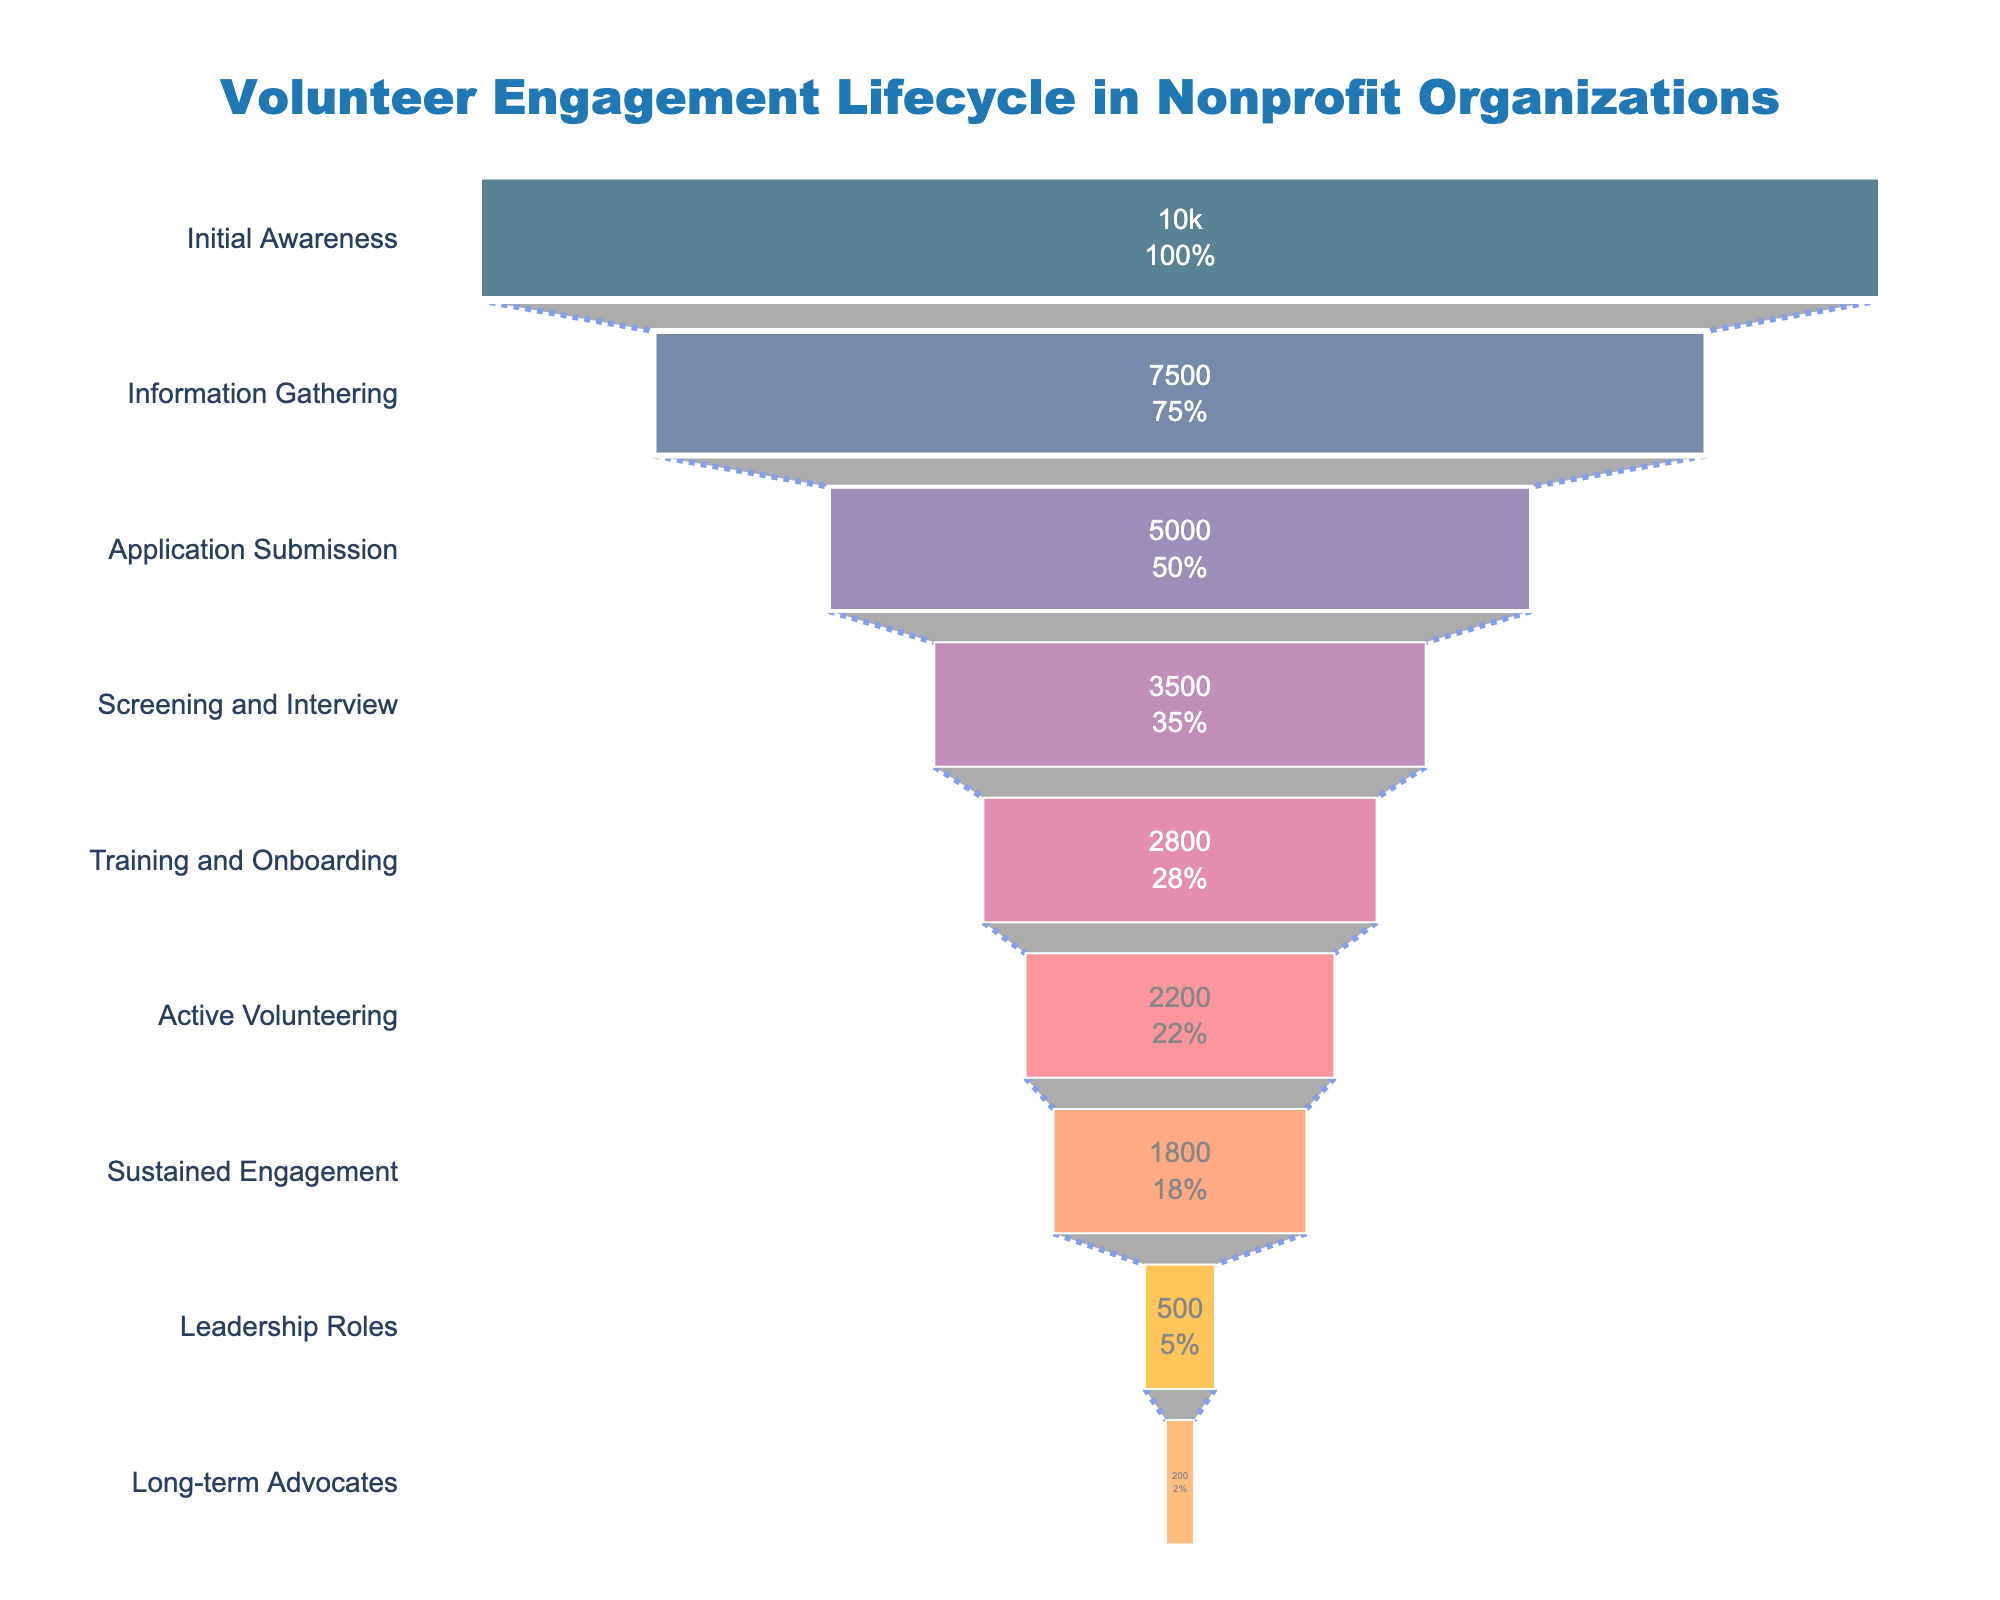What is the total number of volunteers in the "Initial Awareness" stage? Look at the "Initial Awareness" bar in the funnel chart. The value inside the bar indicates the number of volunteers at this stage.
Answer: 10000 How many volunteers remain in the "Training and Onboarding" stage compared to the "Application Submission" stage? First, find the number of volunteers in "Training and Onboarding" which is 2800. Then find the number in "Application Submission" which is 5000. Subtract 2800 from 5000.
Answer: 2200 Which stage has the least number of volunteers? Compare the values inside the bars for each stage. The smallest value represents the stage with the least number of volunteers.
Answer: Long-term Advocates What percentage of the initial volunteers make it to the "Sustained Engagement" stage? Locate the number of volunteers in the "Initial Awareness" stage (10000) and the "Sustained Engagement" stage (1800). The percentage is calculated as (1800/10000) * 100.
Answer: 18% Is the drop from "Training and Onboarding" to "Active Volunteering" less significant compared to the drop from "Application Submission" to "Screening and Interview"? From "Training and Onboarding" to "Active Volunteering" the drop is 2800 - 2200 = 600. From "Application Submission" to "Screening and Interview," the drop is 5000 - 3500 = 1500. Compare the drops.
Answer: Yes What is the color of the "Information Gathering" stage bar? View the "Information Gathering" bar and describe its color.
Answer: Dark blue How many stages are there in the volunteer engagement lifecycle? Count the number of distinct stages labeled on the y-axis of the funnel chart.
Answer: 9 Between which two stages is there the largest drop in the number of volunteers? Calculate the drop between consecutive stages and find the largest difference. Initial Awareness to Information Gathering (2500), Information Gathering to Application Submission (2500), Application Submission to Screening and Interview (1500), Screening and Interview to Training and Onboarding (700), Training and Onboarding to Active Volunteering (600), Active Volunteering to Sustained Engagement (400), Sustained Engagement to Leadership Roles (1300), Leadership Roles to Long-term Advocates (300). The largest drop is either Initial Awareness to Information Gathering or Information Gathering to Application Submission (2500).
Answer: Information Gathering to Application Submission 